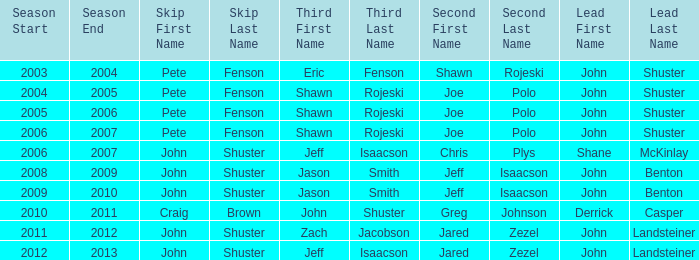Who was second when Shane McKinlay was the lead? Chris Plys. 